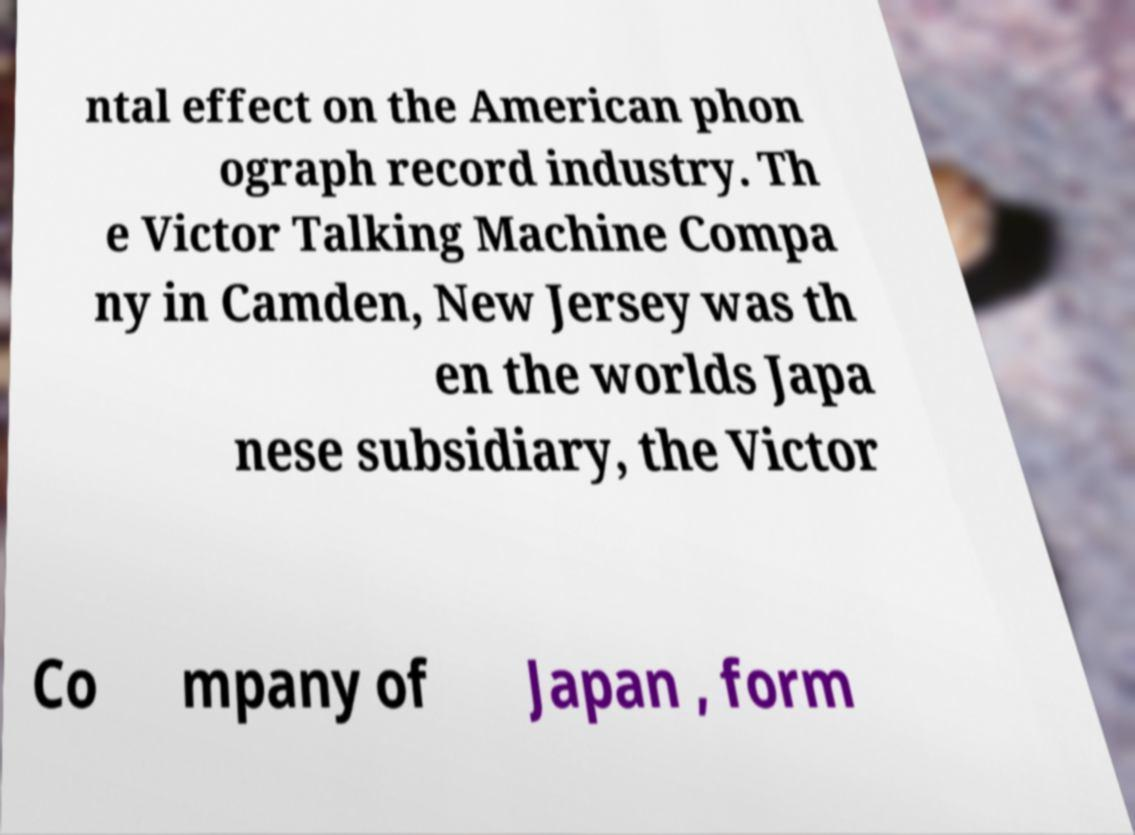I need the written content from this picture converted into text. Can you do that? ntal effect on the American phon ograph record industry. Th e Victor Talking Machine Compa ny in Camden, New Jersey was th en the worlds Japa nese subsidiary, the Victor Co mpany of Japan , form 